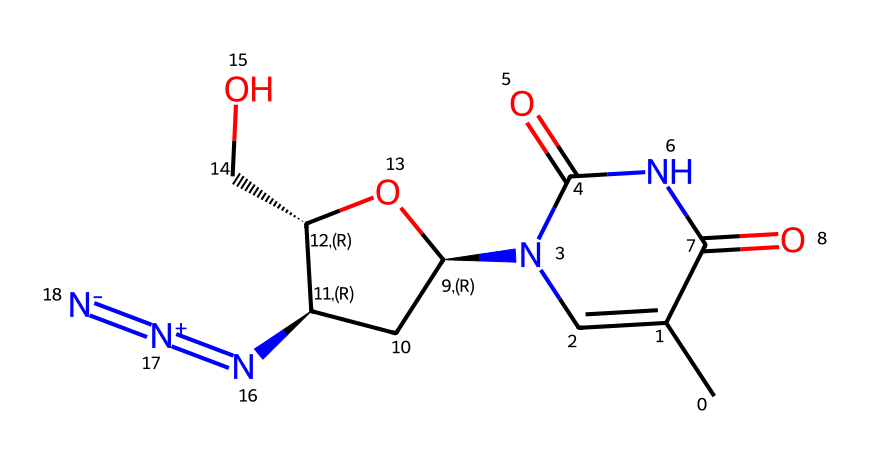What is the total number of carbon atoms in Azidothymidine (AZT)? By examining the SMILES representation, we can count the number of carbon atoms (C). In this case, there are six individual 'C' symbols present, indicating a total of six carbon atoms in the structure.
Answer: 6 How many nitrogen atoms are present in this molecule? The SMILES shows several representations of nitrogen (N). Counting these symbols, we find there are three nitrogen atoms, indicating their presence in the structure of Azidothymidine (AZT).
Answer: 3 What functional group is indicated by the presence of N=[N+]=[N-]? This part of the SMILES represents an azide functional group, which consists of three connected nitrogen atoms where the terminal nitrogen is negatively charged, and the central nitrogen is positively charged. This describes the unique azide feature present in AZT.
Answer: azide What is the type of bond connecting the nitrogen atoms in the azide group? The representation N=[N+]=[N-] specifies that there are double bonds between the nitrogen atoms; specifically, there are two double bonds involved in forming the azide group, characterizing the strong interactions present within azides.
Answer: double bond What type of structure does Azidothymidine (AZT) resemble due to its molecular components? Analyzing the structure, we observe that it has characteristics similar to thymidine, a nucleoside, as it contains both thymine and sugar components in its structure, linking it pharmacologically to antiviral action.
Answer: nucleoside How many total rings are present in the Azidothymidine (AZT) structure? From the interpretation of the SMILES, we can identify one cyclic structure indicated by the presence of 'C1' and corresponding bond closures. Thus, Azidothymidine (AZT) features one ring in its molecular structure.
Answer: 1 